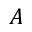<formula> <loc_0><loc_0><loc_500><loc_500>A</formula> 